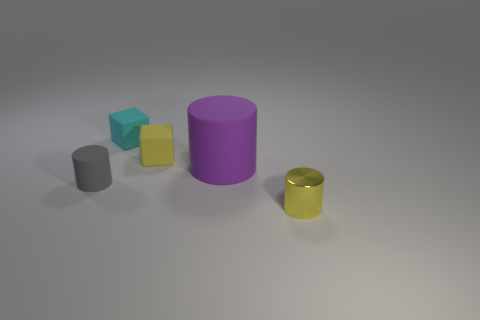How many other objects are the same material as the gray cylinder?
Your answer should be very brief. 3. How many metallic things are either large gray cylinders or gray cylinders?
Offer a very short reply. 0. What color is the small matte thing that is the same shape as the tiny yellow shiny thing?
Keep it short and to the point. Gray. What number of objects are either small matte cylinders or purple cylinders?
Give a very brief answer. 2. There is a small yellow thing that is made of the same material as the tiny cyan cube; what is its shape?
Keep it short and to the point. Cube. What number of big objects are either yellow metal cylinders or purple metal cubes?
Provide a succinct answer. 0. What number of other things are the same color as the big cylinder?
Give a very brief answer. 0. How many yellow rubber things are on the right side of the tiny yellow object on the left side of the small thing that is in front of the tiny matte cylinder?
Offer a very short reply. 0. Does the cube on the right side of the cyan cube have the same size as the yellow metal object?
Your answer should be compact. Yes. Are there fewer small gray objects that are in front of the yellow shiny cylinder than tiny cubes on the right side of the small cyan matte block?
Your answer should be compact. Yes. 